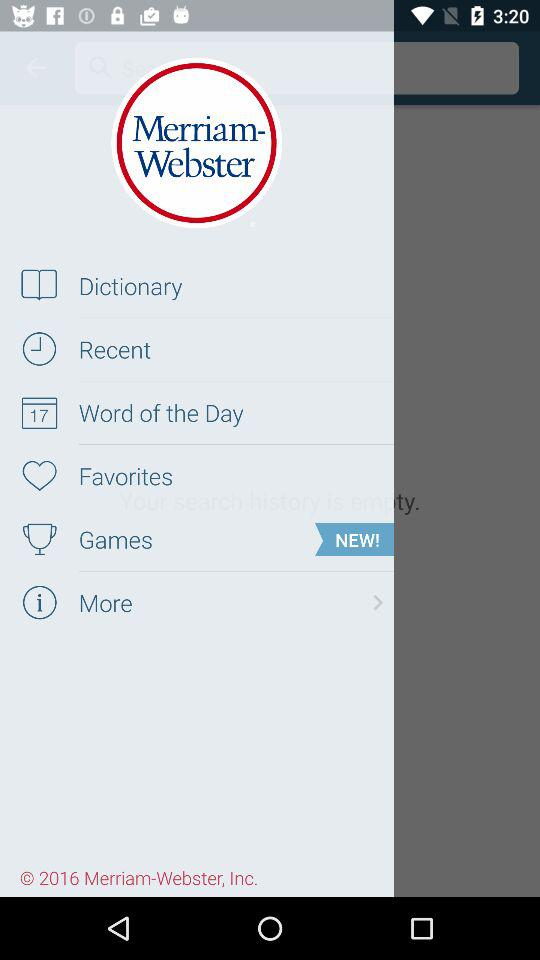Is there anything new in games?
When the provided information is insufficient, respond with <no answer>. <no answer> 